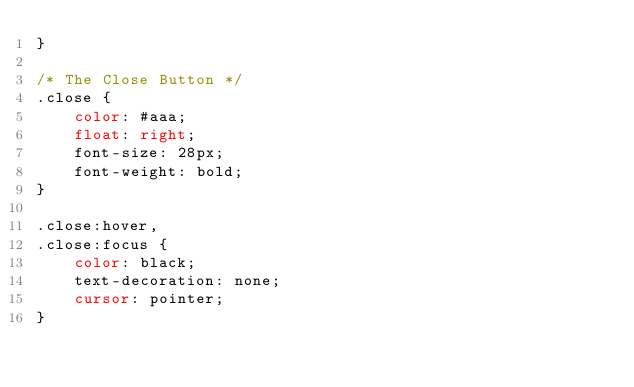<code> <loc_0><loc_0><loc_500><loc_500><_CSS_>}

/* The Close Button */
.close {
    color: #aaa;
    float: right;
    font-size: 28px;
    font-weight: bold;
}

.close:hover,
.close:focus {
    color: black;
    text-decoration: none;
    cursor: pointer;
}</code> 